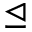Convert formula to latex. <formula><loc_0><loc_0><loc_500><loc_500>\triangleleft e q</formula> 